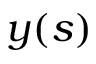<formula> <loc_0><loc_0><loc_500><loc_500>\boldsymbol y ( s )</formula> 